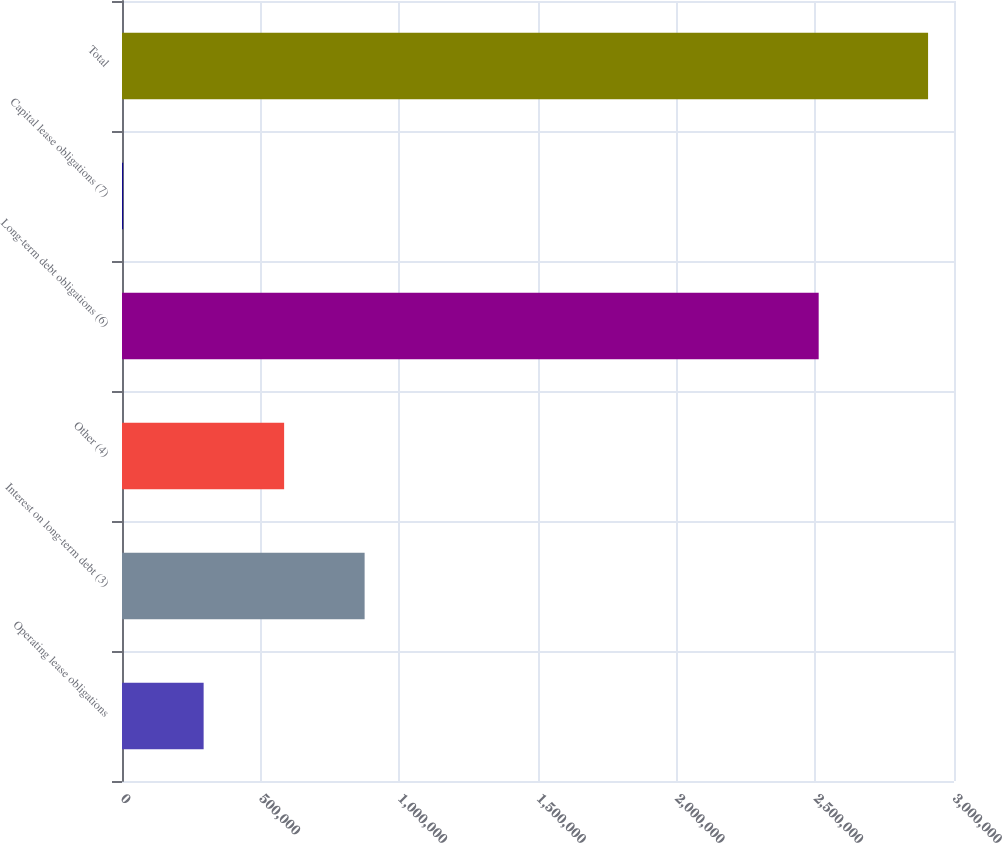Convert chart. <chart><loc_0><loc_0><loc_500><loc_500><bar_chart><fcel>Operating lease obligations<fcel>Interest on long-term debt (3)<fcel>Other (4)<fcel>Long-term debt obligations (6)<fcel>Capital lease obligations (7)<fcel>Total<nl><fcel>294347<fcel>874826<fcel>584586<fcel>2.51208e+06<fcel>4107<fcel>2.9065e+06<nl></chart> 